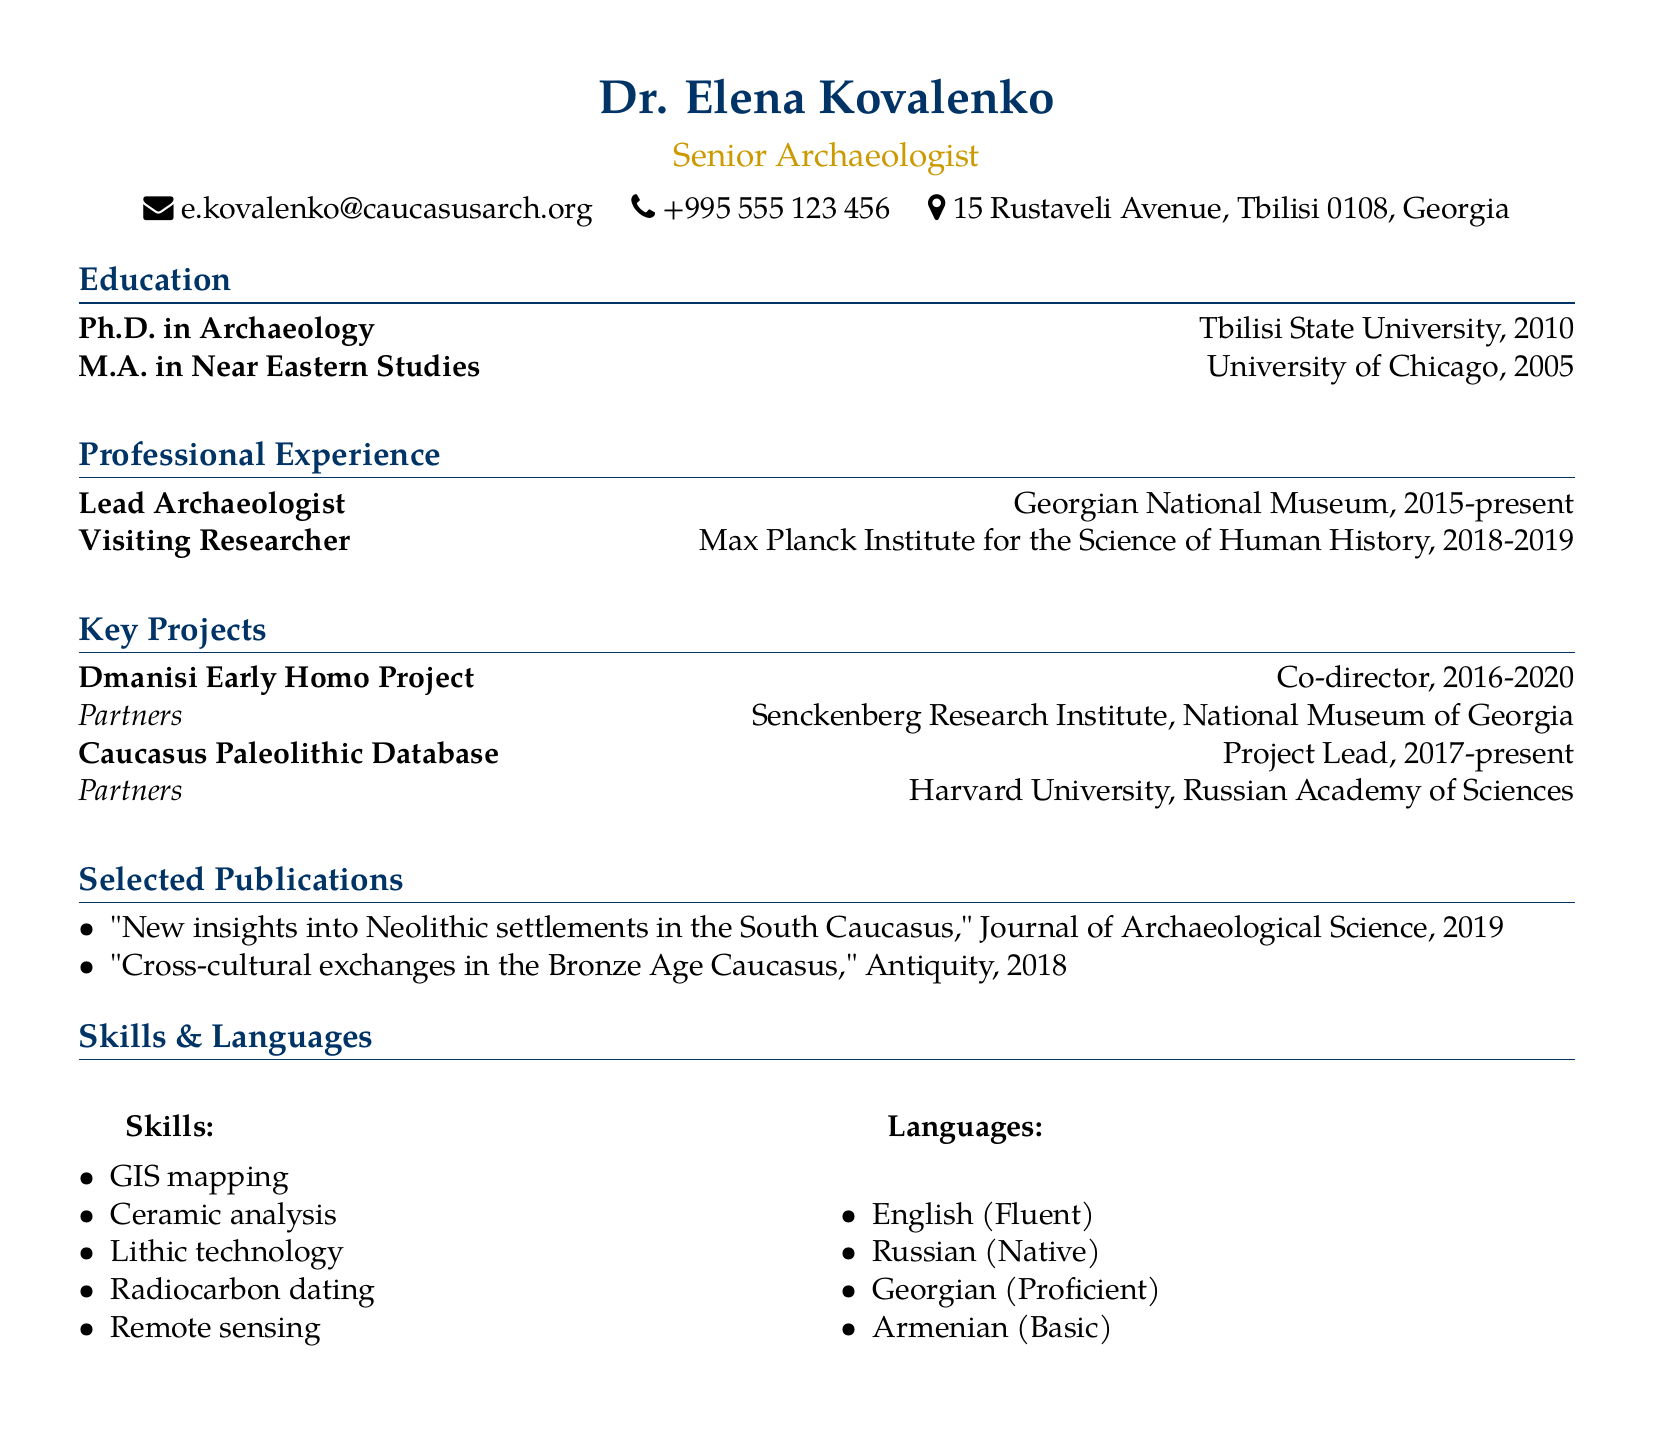What is the name of the Senior Archaeologist? The name of the Senior Archaeologist is listed at the top of the document.
Answer: Dr. Elena Kovalenko Where does Dr. Kovalenko work currently? The document specifies the current position and institution where Dr. Kovalenko works.
Answer: Georgian National Museum What year did Dr. Kovalenko obtain her Ph.D.? The year is specified under the education section of the document.
Answer: 2010 In which project did Dr. Kovalenko serve as Co-director? The key projects section lists the roles and names of the projects.
Answer: Dmanisi Early Homo Project How many languages does Dr. Kovalenko speak? The document lists the languages in the skills section.
Answer: Four Which university did Dr. Kovalenko attend for her Master's degree? The education section provides the details of Dr. Kovalenko's Master's degree.
Answer: University of Chicago Who are the partners in the Caucasus Paleolithic Database project? The partners are listed under the key projects section.
Answer: Harvard University, Russian Academy of Sciences What is one of Dr. Kovalenko's skills? The skills section contains various skills Dr. Kovalenko possesses.
Answer: GIS mapping During which years was Dr. Kovalenko a Visiting Researcher? The professional experience section details the duration of her position.
Answer: 2018-2019 